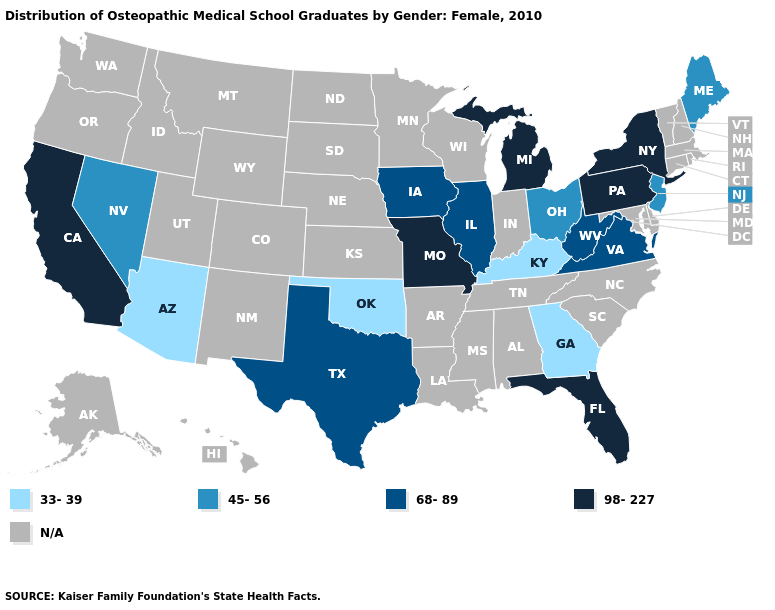Among the states that border Indiana , does Illinois have the lowest value?
Give a very brief answer. No. How many symbols are there in the legend?
Concise answer only. 5. What is the value of Michigan?
Keep it brief. 98-227. Name the states that have a value in the range N/A?
Be succinct. Alabama, Alaska, Arkansas, Colorado, Connecticut, Delaware, Hawaii, Idaho, Indiana, Kansas, Louisiana, Maryland, Massachusetts, Minnesota, Mississippi, Montana, Nebraska, New Hampshire, New Mexico, North Carolina, North Dakota, Oregon, Rhode Island, South Carolina, South Dakota, Tennessee, Utah, Vermont, Washington, Wisconsin, Wyoming. Does the map have missing data?
Keep it brief. Yes. Which states have the highest value in the USA?
Short answer required. California, Florida, Michigan, Missouri, New York, Pennsylvania. What is the highest value in the USA?
Short answer required. 98-227. Name the states that have a value in the range N/A?
Answer briefly. Alabama, Alaska, Arkansas, Colorado, Connecticut, Delaware, Hawaii, Idaho, Indiana, Kansas, Louisiana, Maryland, Massachusetts, Minnesota, Mississippi, Montana, Nebraska, New Hampshire, New Mexico, North Carolina, North Dakota, Oregon, Rhode Island, South Carolina, South Dakota, Tennessee, Utah, Vermont, Washington, Wisconsin, Wyoming. What is the highest value in the USA?
Be succinct. 98-227. Name the states that have a value in the range 68-89?
Keep it brief. Illinois, Iowa, Texas, Virginia, West Virginia. Name the states that have a value in the range 98-227?
Quick response, please. California, Florida, Michigan, Missouri, New York, Pennsylvania. 